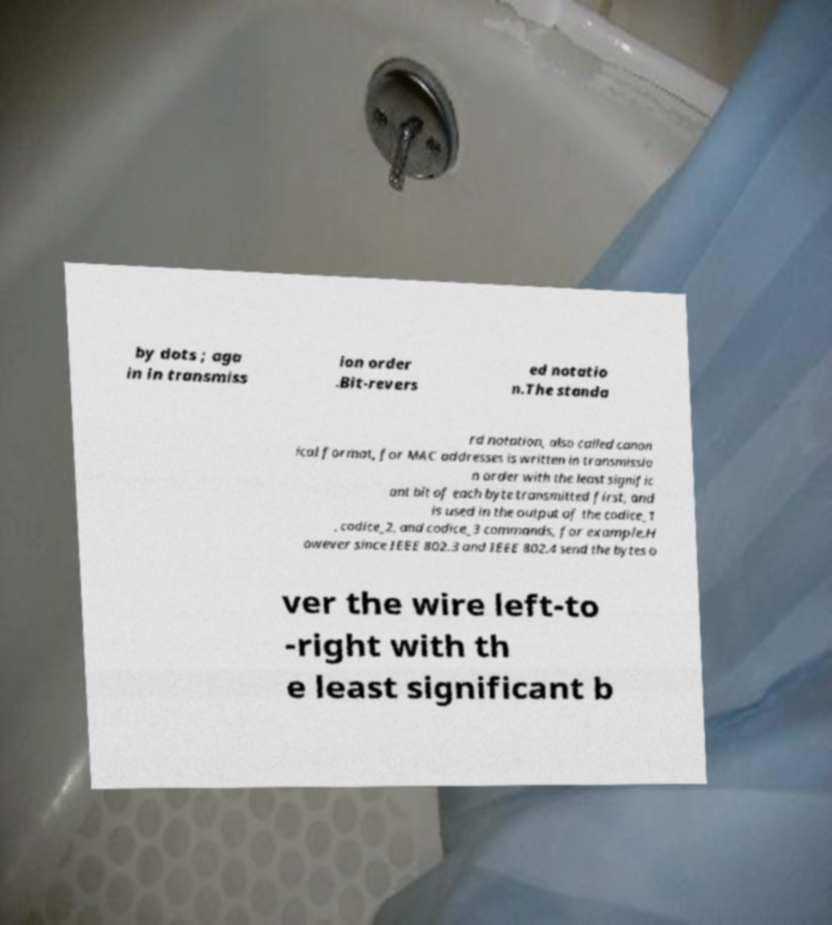Can you read and provide the text displayed in the image?This photo seems to have some interesting text. Can you extract and type it out for me? by dots ; aga in in transmiss ion order .Bit-revers ed notatio n.The standa rd notation, also called canon ical format, for MAC addresses is written in transmissio n order with the least signific ant bit of each byte transmitted first, and is used in the output of the codice_1 , codice_2, and codice_3 commands, for example.H owever since IEEE 802.3 and IEEE 802.4 send the bytes o ver the wire left-to -right with th e least significant b 